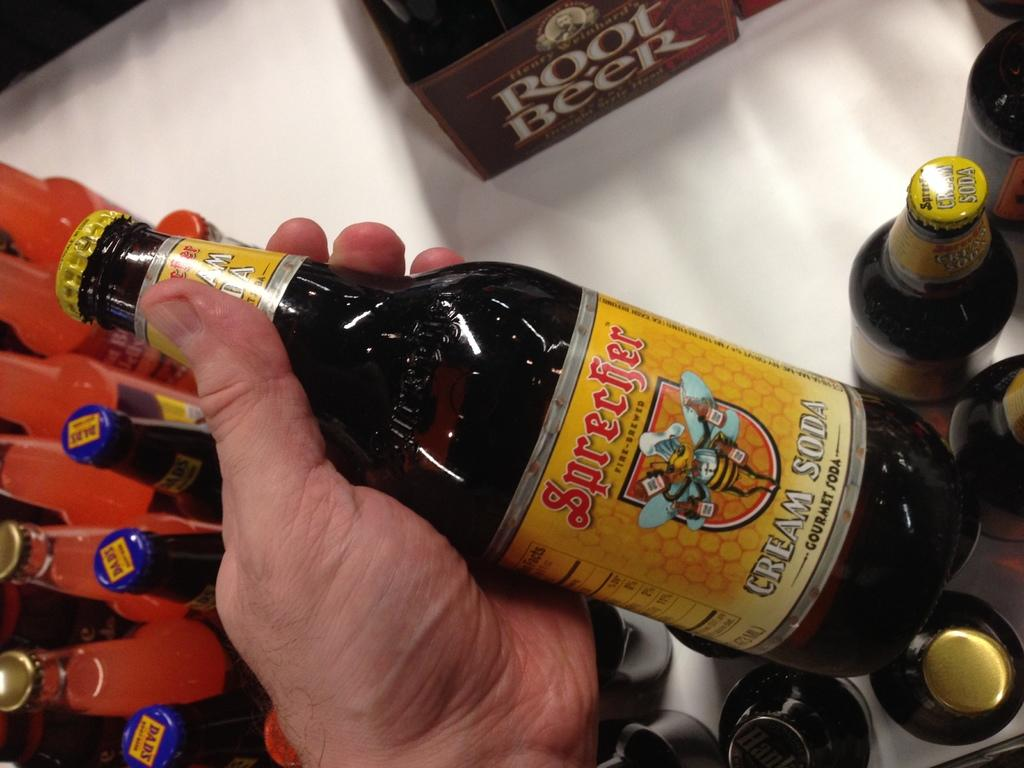<image>
Summarize the visual content of the image. A hand holding a yellow-labeled Sprecher Cream Soda above a table with other bottles of sodas, including root beer. 